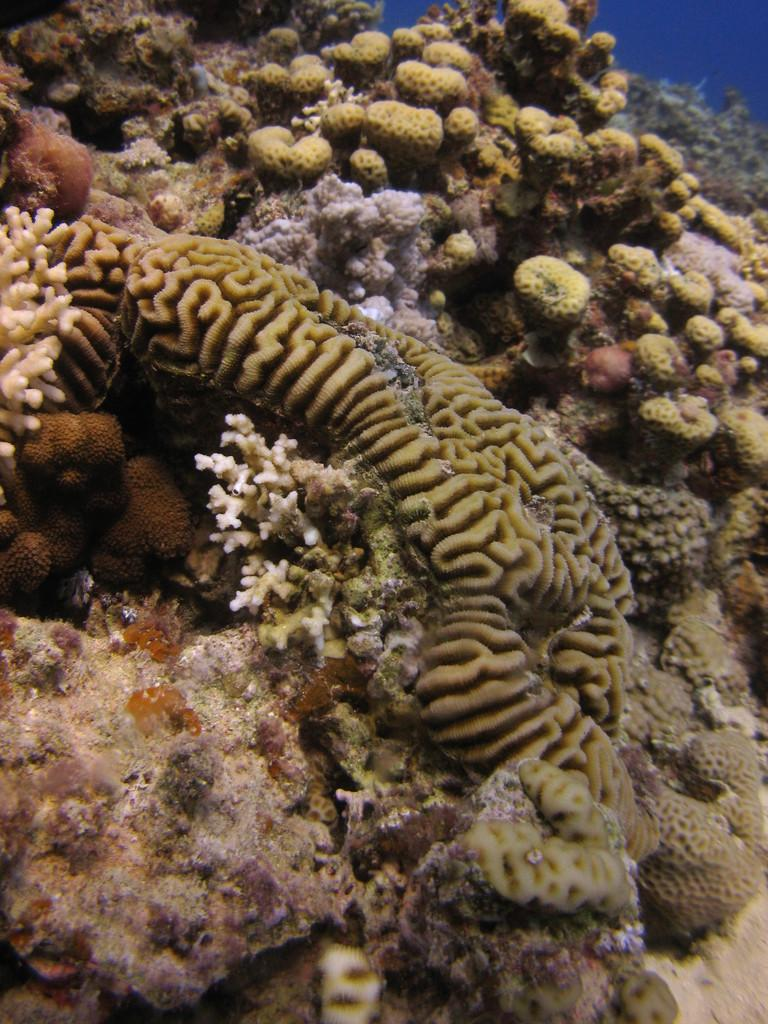What type of environment is shown in the image? The image depicts an underwater environment. What can be found in this underwater environment? There are coral plants in the image. How many brothers are swimming with the coral plants in the image? There are no brothers swimming in the image; it depicts an underwater environment with coral plants. 